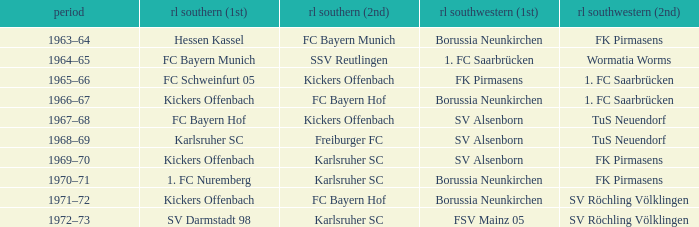What season was Freiburger FC the RL Süd (2nd) team? 1968–69. 